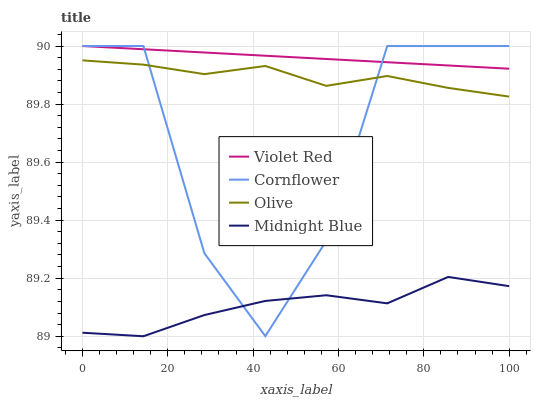Does Midnight Blue have the minimum area under the curve?
Answer yes or no. Yes. Does Violet Red have the maximum area under the curve?
Answer yes or no. Yes. Does Cornflower have the minimum area under the curve?
Answer yes or no. No. Does Cornflower have the maximum area under the curve?
Answer yes or no. No. Is Violet Red the smoothest?
Answer yes or no. Yes. Is Cornflower the roughest?
Answer yes or no. Yes. Is Cornflower the smoothest?
Answer yes or no. No. Is Violet Red the roughest?
Answer yes or no. No. Does Cornflower have the lowest value?
Answer yes or no. No. Does Violet Red have the highest value?
Answer yes or no. Yes. Does Midnight Blue have the highest value?
Answer yes or no. No. Is Midnight Blue less than Violet Red?
Answer yes or no. Yes. Is Olive greater than Midnight Blue?
Answer yes or no. Yes. Does Cornflower intersect Midnight Blue?
Answer yes or no. Yes. Is Cornflower less than Midnight Blue?
Answer yes or no. No. Is Cornflower greater than Midnight Blue?
Answer yes or no. No. Does Midnight Blue intersect Violet Red?
Answer yes or no. No. 